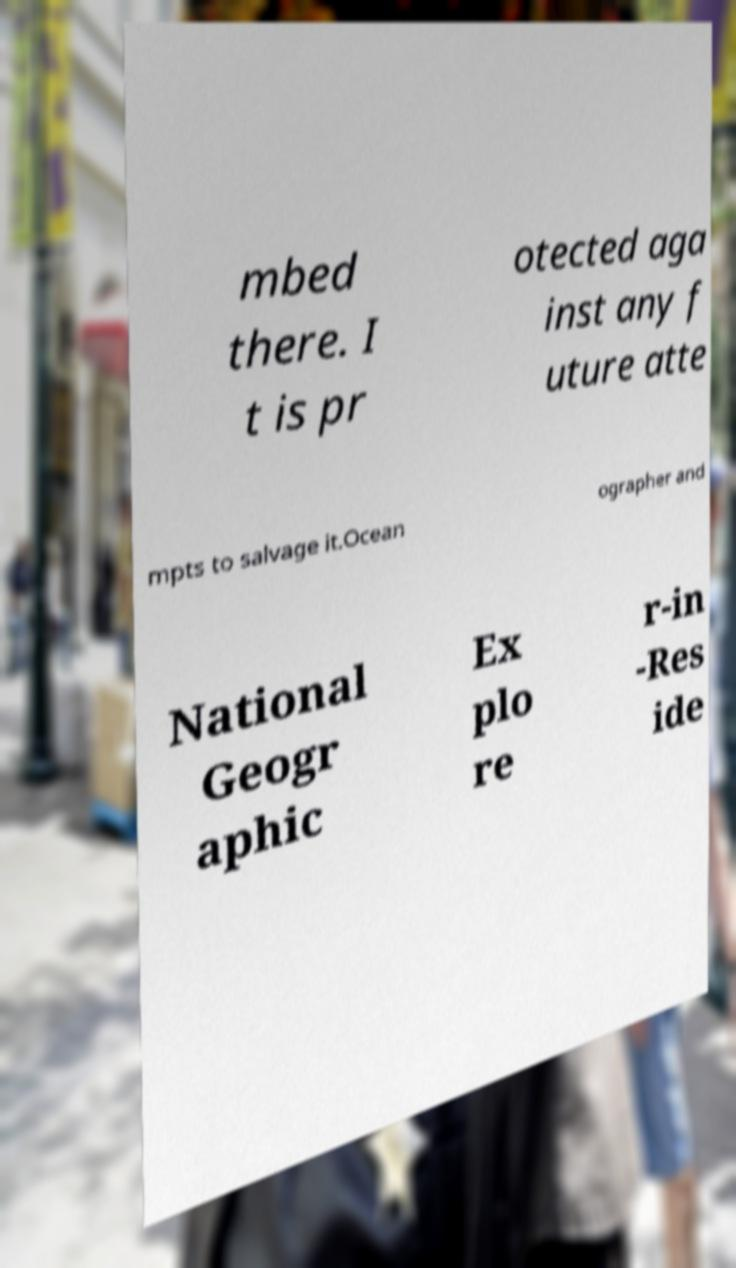There's text embedded in this image that I need extracted. Can you transcribe it verbatim? mbed there. I t is pr otected aga inst any f uture atte mpts to salvage it.Ocean ographer and National Geogr aphic Ex plo re r-in -Res ide 